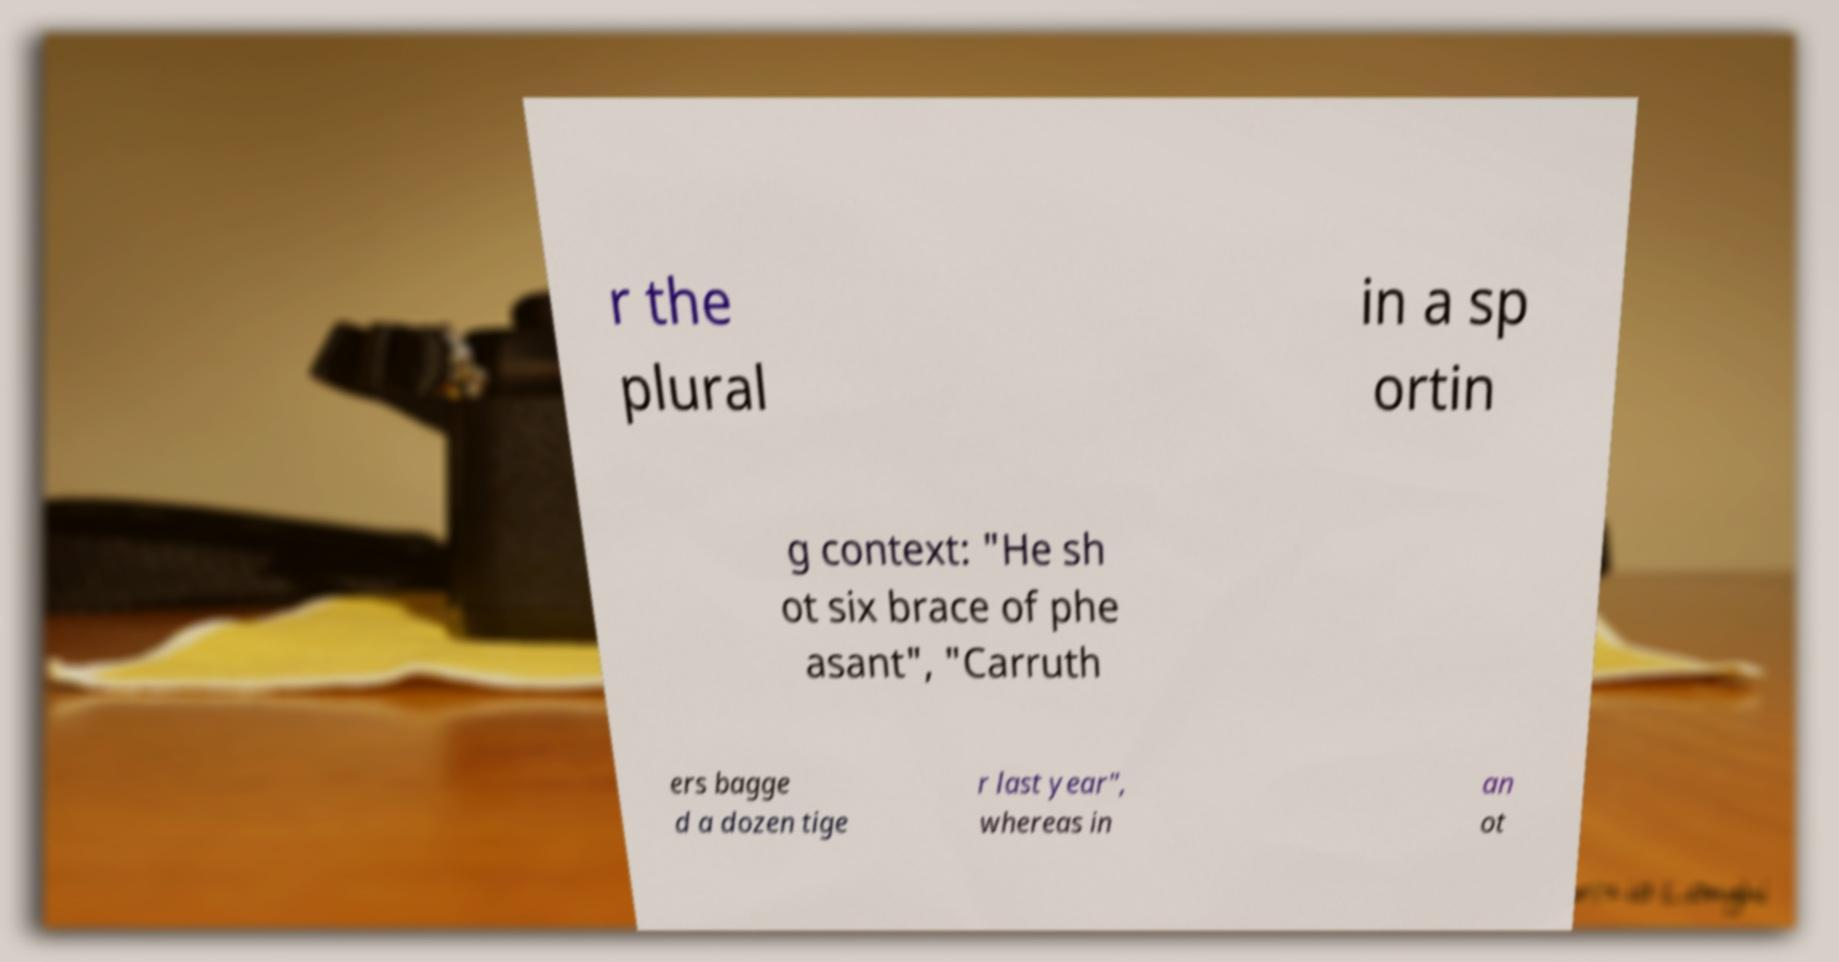Please read and relay the text visible in this image. What does it say? r the plural in a sp ortin g context: "He sh ot six brace of phe asant", "Carruth ers bagge d a dozen tige r last year", whereas in an ot 